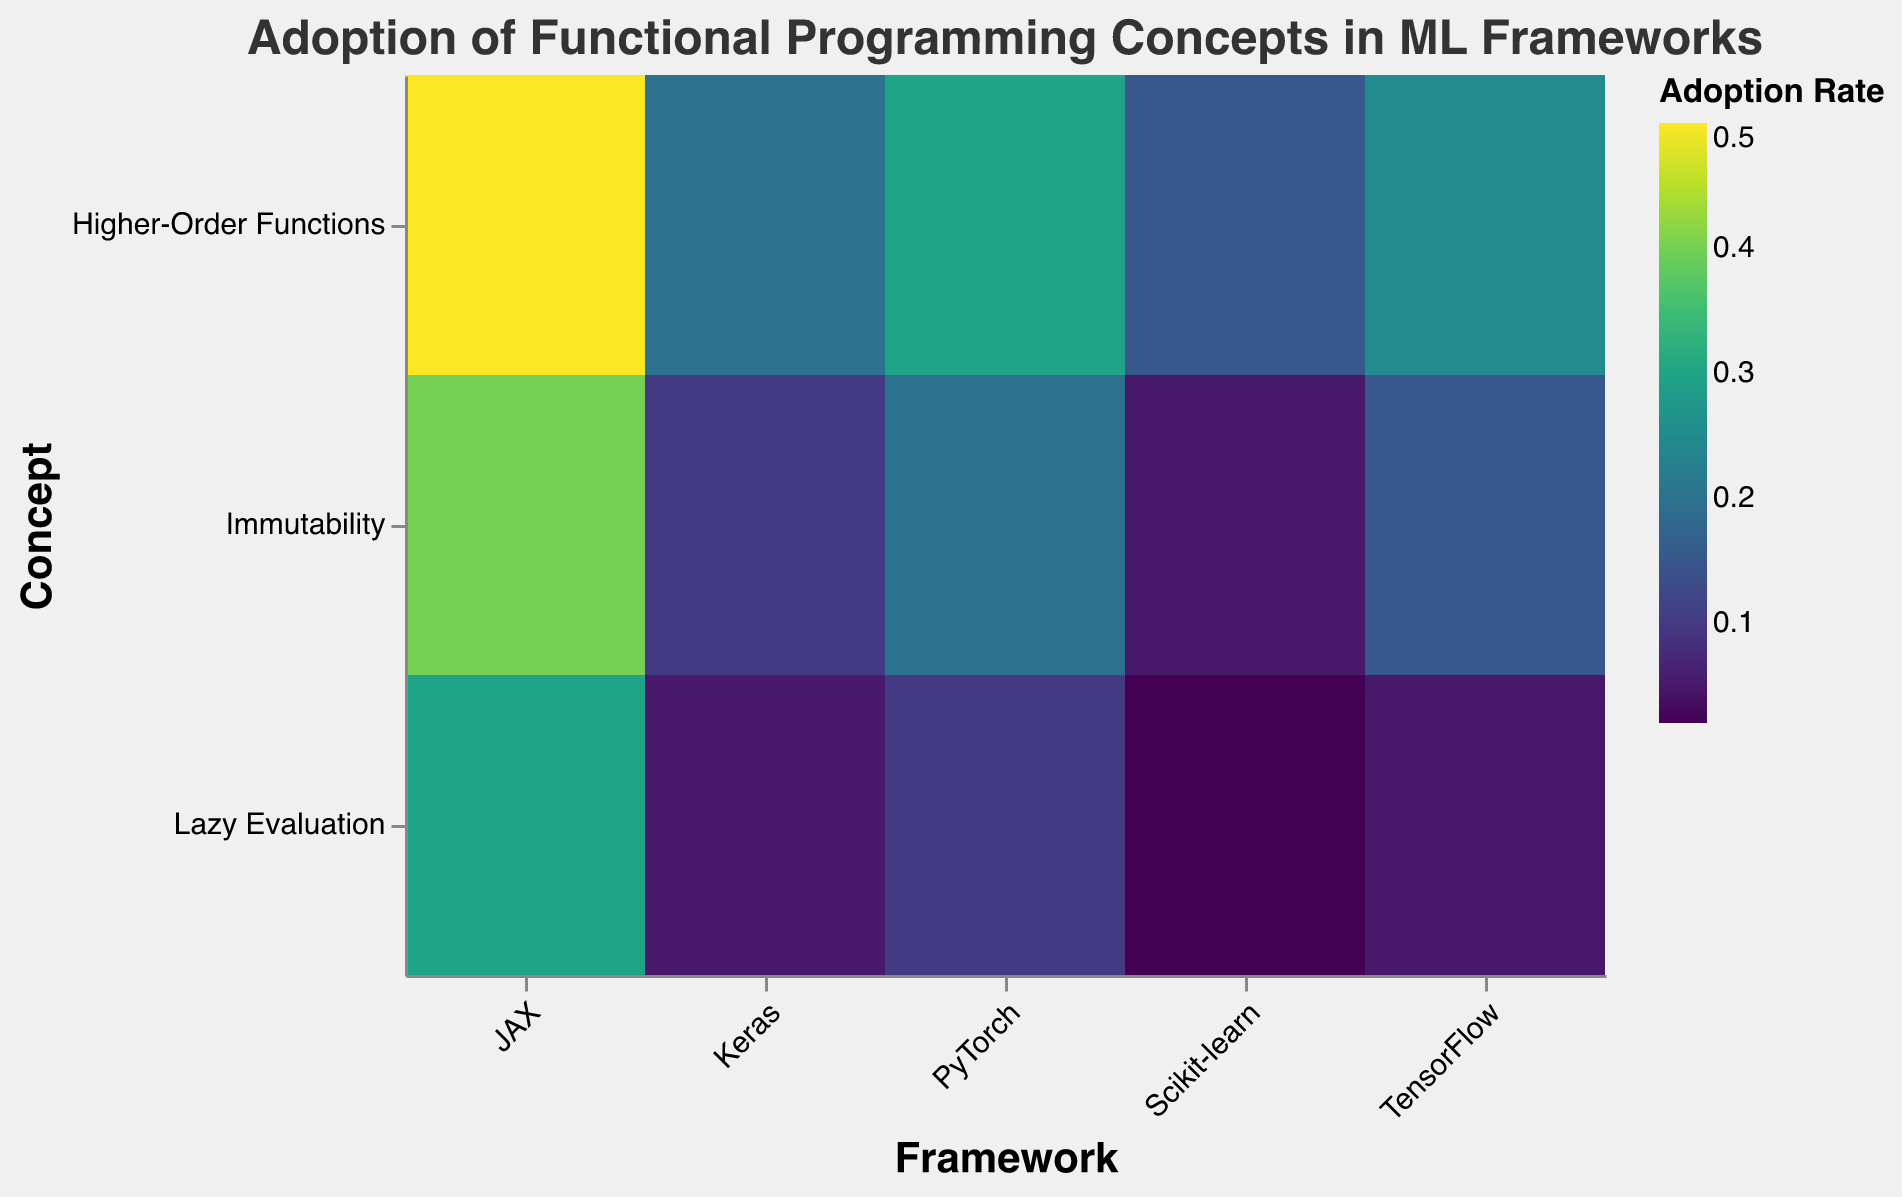What is the title of the figure? The title of the figure is displayed at the top. It reads "Adoption of Functional Programming Concepts in ML Frameworks".
Answer: "Adoption of Functional Programming Concepts in ML Frameworks" Which framework has the highest adoption rate for immutability? To determine this, look at the y-axis for "Immutability" and then check the color intensity and size of the rectangles in the corresponding row. The darkest and largest rectangle indicates the highest adoption rate, which is for the JAX framework.
Answer: JAX What is the lowest adoption rate for any concept in Scikit-learn? Examine the Scikit-learn column. Lazy Evaluation is represented by the lightest and smallest rectangle in this column with an adoption rate of 0.02.
Answer: 0.02 Compare the adoption rates of higher-order functions in TensorFlow and PyTorch. Which one is greater? Locate the "Higher-Order Functions" row and compare the rectangles under TensorFlow and PyTorch. The PyTorch rectangle is larger and darker, indicating it has a higher adoption rate of 0.30 compared to TensorFlow's 0.25.
Answer: PyTorch What concept in Keras has the same adoption rate as lazy evaluation in TensorFlow? Look at the row for "Lazy Evaluation" in the TensorFlow column, which has an adoption rate of 0.05. Then find a rectangle with the same adoption rate in the Keras column. The "Lazy Evaluation" in Keras also has an adoption rate of 0.05.
Answer: Lazy Evaluation Which framework has the most balanced adoption rates across all concepts? A balanced adoption rate means the rectangles should have similar sizes and color intensities. PyTorch's rectangles appear to have the smallest variation in size and color compared to other frameworks.
Answer: PyTorch What is the average adoption rate of higher-order functions across all frameworks? Add the adoption rates for higher-order functions across all frameworks: (0.25 for TensorFlow + 0.30 for PyTorch + 0.20 for Keras + 0.15 for Scikit-learn + 0.50 for JAX) and then divide by 5 frameworks. The calculation is (0.25 + 0.30 + 0.20 + 0.15 + 0.50) / 5 = 1.40 / 5 = 0.28.
Answer: 0.28 Identify which framework has the most extreme variation in adoption rates between the three concepts. The framework with the largest disparity between the largest and smallest adoption rates can be found by comparing the highest and lowest values. For JAX: 0.50 (higher-order) - 0.30 (lazy evaluation) = 0.20. For PyTorch: 0.30 (higher-order) - 0.10 (lazy evaluation) = 0.20. For TensorFlow: 0.25 - 0.05 = 0.20. For Keras: 0.20 - 0.05 = 0.15. For Scikit-learn: 0.15 - 0.02 = 0.13. The extreme variation of 0.20 is equally seen in JAX, PyTorch, and TensorFlow.
Answer: JAX, PyTorch, TensorFlow Among all frameworks, which combination of concept and framework has the maximum adoption rate? Look at all rectangles and identify the largest and darkest shaded one. The darkest and largest rectangle is in the "Higher-Order Functions" row for JAX with an adoption rate of 0.50.
Answer: Higher-Order Functions in JAX 